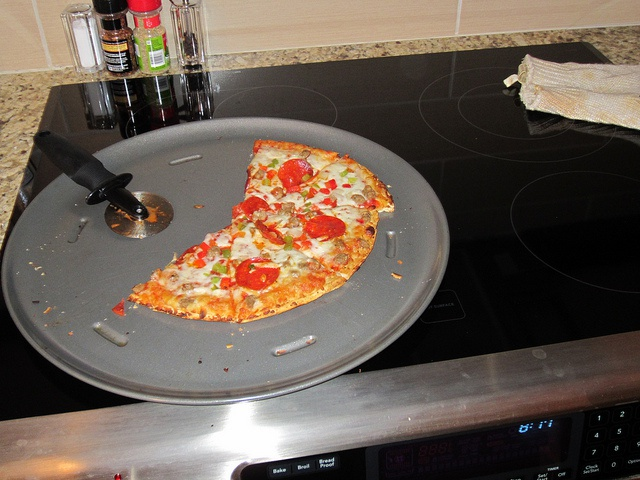Describe the objects in this image and their specific colors. I can see oven in tan, black, darkgray, and gray tones, pizza in tan, red, and orange tones, bottle in tan, black, maroon, gray, and darkgray tones, bottle in tan, red, darkgray, and olive tones, and bottle in tan, darkgray, and gray tones in this image. 